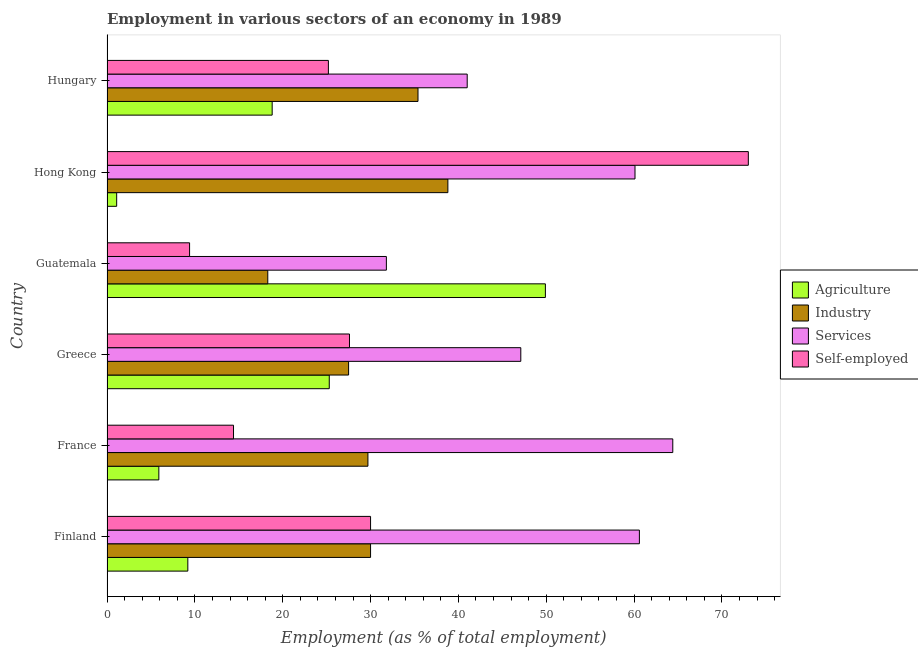How many groups of bars are there?
Make the answer very short. 6. What is the label of the 4th group of bars from the top?
Make the answer very short. Greece. Across all countries, what is the maximum percentage of workers in services?
Ensure brevity in your answer.  64.4. Across all countries, what is the minimum percentage of self employed workers?
Your response must be concise. 9.4. In which country was the percentage of workers in services minimum?
Provide a short and direct response. Guatemala. What is the total percentage of workers in services in the graph?
Provide a succinct answer. 305. What is the difference between the percentage of self employed workers in Finland and that in Greece?
Your answer should be very brief. 2.4. What is the difference between the percentage of workers in services in Guatemala and the percentage of workers in industry in France?
Provide a short and direct response. 2.1. What is the average percentage of workers in services per country?
Your answer should be compact. 50.83. What is the difference between the percentage of self employed workers and percentage of workers in industry in France?
Your answer should be compact. -15.3. In how many countries, is the percentage of workers in services greater than 60 %?
Keep it short and to the point. 3. What is the ratio of the percentage of workers in services in France to that in Guatemala?
Your response must be concise. 2.02. Is the percentage of workers in agriculture in Greece less than that in Hong Kong?
Provide a succinct answer. No. Is the difference between the percentage of workers in industry in Greece and Hong Kong greater than the difference between the percentage of workers in services in Greece and Hong Kong?
Provide a succinct answer. Yes. What is the difference between the highest and the second highest percentage of self employed workers?
Your answer should be very brief. 43. What does the 3rd bar from the top in Guatemala represents?
Keep it short and to the point. Industry. What does the 1st bar from the bottom in France represents?
Keep it short and to the point. Agriculture. Are all the bars in the graph horizontal?
Keep it short and to the point. Yes. How many legend labels are there?
Your answer should be very brief. 4. How are the legend labels stacked?
Keep it short and to the point. Vertical. What is the title of the graph?
Make the answer very short. Employment in various sectors of an economy in 1989. What is the label or title of the X-axis?
Offer a very short reply. Employment (as % of total employment). What is the Employment (as % of total employment) of Agriculture in Finland?
Keep it short and to the point. 9.2. What is the Employment (as % of total employment) of Services in Finland?
Provide a short and direct response. 60.6. What is the Employment (as % of total employment) in Self-employed in Finland?
Make the answer very short. 30. What is the Employment (as % of total employment) of Agriculture in France?
Keep it short and to the point. 5.9. What is the Employment (as % of total employment) of Industry in France?
Your answer should be very brief. 29.7. What is the Employment (as % of total employment) in Services in France?
Make the answer very short. 64.4. What is the Employment (as % of total employment) in Self-employed in France?
Your response must be concise. 14.4. What is the Employment (as % of total employment) of Agriculture in Greece?
Offer a terse response. 25.3. What is the Employment (as % of total employment) of Services in Greece?
Offer a very short reply. 47.1. What is the Employment (as % of total employment) in Self-employed in Greece?
Offer a very short reply. 27.6. What is the Employment (as % of total employment) of Agriculture in Guatemala?
Your answer should be compact. 49.9. What is the Employment (as % of total employment) of Industry in Guatemala?
Provide a succinct answer. 18.3. What is the Employment (as % of total employment) of Services in Guatemala?
Provide a short and direct response. 31.8. What is the Employment (as % of total employment) in Self-employed in Guatemala?
Ensure brevity in your answer.  9.4. What is the Employment (as % of total employment) in Agriculture in Hong Kong?
Your response must be concise. 1.1. What is the Employment (as % of total employment) of Industry in Hong Kong?
Your response must be concise. 38.8. What is the Employment (as % of total employment) in Services in Hong Kong?
Ensure brevity in your answer.  60.1. What is the Employment (as % of total employment) in Self-employed in Hong Kong?
Ensure brevity in your answer.  73. What is the Employment (as % of total employment) in Agriculture in Hungary?
Ensure brevity in your answer.  18.8. What is the Employment (as % of total employment) of Industry in Hungary?
Offer a very short reply. 35.4. What is the Employment (as % of total employment) of Self-employed in Hungary?
Ensure brevity in your answer.  25.2. Across all countries, what is the maximum Employment (as % of total employment) in Agriculture?
Provide a succinct answer. 49.9. Across all countries, what is the maximum Employment (as % of total employment) of Industry?
Your answer should be very brief. 38.8. Across all countries, what is the maximum Employment (as % of total employment) in Services?
Offer a very short reply. 64.4. Across all countries, what is the minimum Employment (as % of total employment) in Agriculture?
Your answer should be compact. 1.1. Across all countries, what is the minimum Employment (as % of total employment) of Industry?
Give a very brief answer. 18.3. Across all countries, what is the minimum Employment (as % of total employment) in Services?
Keep it short and to the point. 31.8. Across all countries, what is the minimum Employment (as % of total employment) in Self-employed?
Give a very brief answer. 9.4. What is the total Employment (as % of total employment) of Agriculture in the graph?
Provide a short and direct response. 110.2. What is the total Employment (as % of total employment) of Industry in the graph?
Offer a very short reply. 179.7. What is the total Employment (as % of total employment) of Services in the graph?
Offer a very short reply. 305. What is the total Employment (as % of total employment) in Self-employed in the graph?
Your answer should be compact. 179.6. What is the difference between the Employment (as % of total employment) in Agriculture in Finland and that in France?
Your answer should be compact. 3.3. What is the difference between the Employment (as % of total employment) of Industry in Finland and that in France?
Give a very brief answer. 0.3. What is the difference between the Employment (as % of total employment) of Services in Finland and that in France?
Offer a very short reply. -3.8. What is the difference between the Employment (as % of total employment) in Self-employed in Finland and that in France?
Give a very brief answer. 15.6. What is the difference between the Employment (as % of total employment) of Agriculture in Finland and that in Greece?
Provide a short and direct response. -16.1. What is the difference between the Employment (as % of total employment) in Agriculture in Finland and that in Guatemala?
Provide a succinct answer. -40.7. What is the difference between the Employment (as % of total employment) of Services in Finland and that in Guatemala?
Your answer should be compact. 28.8. What is the difference between the Employment (as % of total employment) in Self-employed in Finland and that in Guatemala?
Ensure brevity in your answer.  20.6. What is the difference between the Employment (as % of total employment) of Agriculture in Finland and that in Hong Kong?
Your response must be concise. 8.1. What is the difference between the Employment (as % of total employment) of Services in Finland and that in Hong Kong?
Give a very brief answer. 0.5. What is the difference between the Employment (as % of total employment) of Self-employed in Finland and that in Hong Kong?
Provide a succinct answer. -43. What is the difference between the Employment (as % of total employment) in Agriculture in Finland and that in Hungary?
Your response must be concise. -9.6. What is the difference between the Employment (as % of total employment) of Industry in Finland and that in Hungary?
Give a very brief answer. -5.4. What is the difference between the Employment (as % of total employment) of Services in Finland and that in Hungary?
Provide a succinct answer. 19.6. What is the difference between the Employment (as % of total employment) in Self-employed in Finland and that in Hungary?
Provide a succinct answer. 4.8. What is the difference between the Employment (as % of total employment) of Agriculture in France and that in Greece?
Provide a short and direct response. -19.4. What is the difference between the Employment (as % of total employment) in Industry in France and that in Greece?
Offer a terse response. 2.2. What is the difference between the Employment (as % of total employment) of Agriculture in France and that in Guatemala?
Your answer should be compact. -44. What is the difference between the Employment (as % of total employment) in Industry in France and that in Guatemala?
Ensure brevity in your answer.  11.4. What is the difference between the Employment (as % of total employment) in Services in France and that in Guatemala?
Your answer should be compact. 32.6. What is the difference between the Employment (as % of total employment) of Self-employed in France and that in Guatemala?
Your answer should be very brief. 5. What is the difference between the Employment (as % of total employment) of Agriculture in France and that in Hong Kong?
Your answer should be very brief. 4.8. What is the difference between the Employment (as % of total employment) of Industry in France and that in Hong Kong?
Your response must be concise. -9.1. What is the difference between the Employment (as % of total employment) of Services in France and that in Hong Kong?
Provide a short and direct response. 4.3. What is the difference between the Employment (as % of total employment) of Self-employed in France and that in Hong Kong?
Your response must be concise. -58.6. What is the difference between the Employment (as % of total employment) of Agriculture in France and that in Hungary?
Offer a terse response. -12.9. What is the difference between the Employment (as % of total employment) in Industry in France and that in Hungary?
Give a very brief answer. -5.7. What is the difference between the Employment (as % of total employment) of Services in France and that in Hungary?
Provide a succinct answer. 23.4. What is the difference between the Employment (as % of total employment) of Self-employed in France and that in Hungary?
Keep it short and to the point. -10.8. What is the difference between the Employment (as % of total employment) of Agriculture in Greece and that in Guatemala?
Provide a succinct answer. -24.6. What is the difference between the Employment (as % of total employment) of Services in Greece and that in Guatemala?
Offer a very short reply. 15.3. What is the difference between the Employment (as % of total employment) in Self-employed in Greece and that in Guatemala?
Offer a very short reply. 18.2. What is the difference between the Employment (as % of total employment) in Agriculture in Greece and that in Hong Kong?
Provide a short and direct response. 24.2. What is the difference between the Employment (as % of total employment) in Industry in Greece and that in Hong Kong?
Make the answer very short. -11.3. What is the difference between the Employment (as % of total employment) in Self-employed in Greece and that in Hong Kong?
Offer a very short reply. -45.4. What is the difference between the Employment (as % of total employment) of Agriculture in Greece and that in Hungary?
Ensure brevity in your answer.  6.5. What is the difference between the Employment (as % of total employment) in Agriculture in Guatemala and that in Hong Kong?
Your answer should be compact. 48.8. What is the difference between the Employment (as % of total employment) of Industry in Guatemala and that in Hong Kong?
Offer a terse response. -20.5. What is the difference between the Employment (as % of total employment) of Services in Guatemala and that in Hong Kong?
Offer a terse response. -28.3. What is the difference between the Employment (as % of total employment) in Self-employed in Guatemala and that in Hong Kong?
Make the answer very short. -63.6. What is the difference between the Employment (as % of total employment) in Agriculture in Guatemala and that in Hungary?
Provide a short and direct response. 31.1. What is the difference between the Employment (as % of total employment) of Industry in Guatemala and that in Hungary?
Your answer should be very brief. -17.1. What is the difference between the Employment (as % of total employment) in Self-employed in Guatemala and that in Hungary?
Offer a terse response. -15.8. What is the difference between the Employment (as % of total employment) in Agriculture in Hong Kong and that in Hungary?
Provide a succinct answer. -17.7. What is the difference between the Employment (as % of total employment) of Self-employed in Hong Kong and that in Hungary?
Offer a very short reply. 47.8. What is the difference between the Employment (as % of total employment) in Agriculture in Finland and the Employment (as % of total employment) in Industry in France?
Provide a short and direct response. -20.5. What is the difference between the Employment (as % of total employment) of Agriculture in Finland and the Employment (as % of total employment) of Services in France?
Provide a short and direct response. -55.2. What is the difference between the Employment (as % of total employment) in Agriculture in Finland and the Employment (as % of total employment) in Self-employed in France?
Offer a very short reply. -5.2. What is the difference between the Employment (as % of total employment) in Industry in Finland and the Employment (as % of total employment) in Services in France?
Ensure brevity in your answer.  -34.4. What is the difference between the Employment (as % of total employment) in Services in Finland and the Employment (as % of total employment) in Self-employed in France?
Provide a succinct answer. 46.2. What is the difference between the Employment (as % of total employment) of Agriculture in Finland and the Employment (as % of total employment) of Industry in Greece?
Give a very brief answer. -18.3. What is the difference between the Employment (as % of total employment) in Agriculture in Finland and the Employment (as % of total employment) in Services in Greece?
Your answer should be very brief. -37.9. What is the difference between the Employment (as % of total employment) of Agriculture in Finland and the Employment (as % of total employment) of Self-employed in Greece?
Your response must be concise. -18.4. What is the difference between the Employment (as % of total employment) in Industry in Finland and the Employment (as % of total employment) in Services in Greece?
Provide a short and direct response. -17.1. What is the difference between the Employment (as % of total employment) in Agriculture in Finland and the Employment (as % of total employment) in Services in Guatemala?
Give a very brief answer. -22.6. What is the difference between the Employment (as % of total employment) of Agriculture in Finland and the Employment (as % of total employment) of Self-employed in Guatemala?
Your answer should be very brief. -0.2. What is the difference between the Employment (as % of total employment) in Industry in Finland and the Employment (as % of total employment) in Self-employed in Guatemala?
Offer a very short reply. 20.6. What is the difference between the Employment (as % of total employment) in Services in Finland and the Employment (as % of total employment) in Self-employed in Guatemala?
Keep it short and to the point. 51.2. What is the difference between the Employment (as % of total employment) of Agriculture in Finland and the Employment (as % of total employment) of Industry in Hong Kong?
Your answer should be compact. -29.6. What is the difference between the Employment (as % of total employment) in Agriculture in Finland and the Employment (as % of total employment) in Services in Hong Kong?
Ensure brevity in your answer.  -50.9. What is the difference between the Employment (as % of total employment) in Agriculture in Finland and the Employment (as % of total employment) in Self-employed in Hong Kong?
Make the answer very short. -63.8. What is the difference between the Employment (as % of total employment) of Industry in Finland and the Employment (as % of total employment) of Services in Hong Kong?
Your response must be concise. -30.1. What is the difference between the Employment (as % of total employment) in Industry in Finland and the Employment (as % of total employment) in Self-employed in Hong Kong?
Offer a terse response. -43. What is the difference between the Employment (as % of total employment) of Services in Finland and the Employment (as % of total employment) of Self-employed in Hong Kong?
Your response must be concise. -12.4. What is the difference between the Employment (as % of total employment) in Agriculture in Finland and the Employment (as % of total employment) in Industry in Hungary?
Provide a short and direct response. -26.2. What is the difference between the Employment (as % of total employment) in Agriculture in Finland and the Employment (as % of total employment) in Services in Hungary?
Offer a terse response. -31.8. What is the difference between the Employment (as % of total employment) in Agriculture in Finland and the Employment (as % of total employment) in Self-employed in Hungary?
Offer a terse response. -16. What is the difference between the Employment (as % of total employment) of Services in Finland and the Employment (as % of total employment) of Self-employed in Hungary?
Your answer should be very brief. 35.4. What is the difference between the Employment (as % of total employment) in Agriculture in France and the Employment (as % of total employment) in Industry in Greece?
Provide a short and direct response. -21.6. What is the difference between the Employment (as % of total employment) in Agriculture in France and the Employment (as % of total employment) in Services in Greece?
Your answer should be compact. -41.2. What is the difference between the Employment (as % of total employment) of Agriculture in France and the Employment (as % of total employment) of Self-employed in Greece?
Your answer should be very brief. -21.7. What is the difference between the Employment (as % of total employment) of Industry in France and the Employment (as % of total employment) of Services in Greece?
Make the answer very short. -17.4. What is the difference between the Employment (as % of total employment) of Services in France and the Employment (as % of total employment) of Self-employed in Greece?
Your answer should be compact. 36.8. What is the difference between the Employment (as % of total employment) in Agriculture in France and the Employment (as % of total employment) in Industry in Guatemala?
Your answer should be very brief. -12.4. What is the difference between the Employment (as % of total employment) of Agriculture in France and the Employment (as % of total employment) of Services in Guatemala?
Make the answer very short. -25.9. What is the difference between the Employment (as % of total employment) in Industry in France and the Employment (as % of total employment) in Self-employed in Guatemala?
Offer a terse response. 20.3. What is the difference between the Employment (as % of total employment) of Services in France and the Employment (as % of total employment) of Self-employed in Guatemala?
Keep it short and to the point. 55. What is the difference between the Employment (as % of total employment) in Agriculture in France and the Employment (as % of total employment) in Industry in Hong Kong?
Provide a short and direct response. -32.9. What is the difference between the Employment (as % of total employment) in Agriculture in France and the Employment (as % of total employment) in Services in Hong Kong?
Provide a succinct answer. -54.2. What is the difference between the Employment (as % of total employment) of Agriculture in France and the Employment (as % of total employment) of Self-employed in Hong Kong?
Make the answer very short. -67.1. What is the difference between the Employment (as % of total employment) in Industry in France and the Employment (as % of total employment) in Services in Hong Kong?
Provide a succinct answer. -30.4. What is the difference between the Employment (as % of total employment) in Industry in France and the Employment (as % of total employment) in Self-employed in Hong Kong?
Provide a succinct answer. -43.3. What is the difference between the Employment (as % of total employment) of Services in France and the Employment (as % of total employment) of Self-employed in Hong Kong?
Provide a succinct answer. -8.6. What is the difference between the Employment (as % of total employment) of Agriculture in France and the Employment (as % of total employment) of Industry in Hungary?
Offer a terse response. -29.5. What is the difference between the Employment (as % of total employment) of Agriculture in France and the Employment (as % of total employment) of Services in Hungary?
Provide a short and direct response. -35.1. What is the difference between the Employment (as % of total employment) of Agriculture in France and the Employment (as % of total employment) of Self-employed in Hungary?
Provide a short and direct response. -19.3. What is the difference between the Employment (as % of total employment) of Industry in France and the Employment (as % of total employment) of Services in Hungary?
Provide a short and direct response. -11.3. What is the difference between the Employment (as % of total employment) in Services in France and the Employment (as % of total employment) in Self-employed in Hungary?
Provide a short and direct response. 39.2. What is the difference between the Employment (as % of total employment) in Agriculture in Greece and the Employment (as % of total employment) in Industry in Guatemala?
Make the answer very short. 7. What is the difference between the Employment (as % of total employment) in Agriculture in Greece and the Employment (as % of total employment) in Services in Guatemala?
Offer a very short reply. -6.5. What is the difference between the Employment (as % of total employment) of Agriculture in Greece and the Employment (as % of total employment) of Self-employed in Guatemala?
Your answer should be compact. 15.9. What is the difference between the Employment (as % of total employment) of Industry in Greece and the Employment (as % of total employment) of Self-employed in Guatemala?
Offer a very short reply. 18.1. What is the difference between the Employment (as % of total employment) in Services in Greece and the Employment (as % of total employment) in Self-employed in Guatemala?
Your answer should be compact. 37.7. What is the difference between the Employment (as % of total employment) in Agriculture in Greece and the Employment (as % of total employment) in Services in Hong Kong?
Give a very brief answer. -34.8. What is the difference between the Employment (as % of total employment) in Agriculture in Greece and the Employment (as % of total employment) in Self-employed in Hong Kong?
Provide a short and direct response. -47.7. What is the difference between the Employment (as % of total employment) in Industry in Greece and the Employment (as % of total employment) in Services in Hong Kong?
Keep it short and to the point. -32.6. What is the difference between the Employment (as % of total employment) in Industry in Greece and the Employment (as % of total employment) in Self-employed in Hong Kong?
Make the answer very short. -45.5. What is the difference between the Employment (as % of total employment) of Services in Greece and the Employment (as % of total employment) of Self-employed in Hong Kong?
Make the answer very short. -25.9. What is the difference between the Employment (as % of total employment) of Agriculture in Greece and the Employment (as % of total employment) of Services in Hungary?
Your answer should be very brief. -15.7. What is the difference between the Employment (as % of total employment) in Industry in Greece and the Employment (as % of total employment) in Self-employed in Hungary?
Provide a short and direct response. 2.3. What is the difference between the Employment (as % of total employment) in Services in Greece and the Employment (as % of total employment) in Self-employed in Hungary?
Give a very brief answer. 21.9. What is the difference between the Employment (as % of total employment) of Agriculture in Guatemala and the Employment (as % of total employment) of Services in Hong Kong?
Keep it short and to the point. -10.2. What is the difference between the Employment (as % of total employment) in Agriculture in Guatemala and the Employment (as % of total employment) in Self-employed in Hong Kong?
Your answer should be very brief. -23.1. What is the difference between the Employment (as % of total employment) of Industry in Guatemala and the Employment (as % of total employment) of Services in Hong Kong?
Your response must be concise. -41.8. What is the difference between the Employment (as % of total employment) in Industry in Guatemala and the Employment (as % of total employment) in Self-employed in Hong Kong?
Offer a very short reply. -54.7. What is the difference between the Employment (as % of total employment) of Services in Guatemala and the Employment (as % of total employment) of Self-employed in Hong Kong?
Offer a very short reply. -41.2. What is the difference between the Employment (as % of total employment) of Agriculture in Guatemala and the Employment (as % of total employment) of Industry in Hungary?
Ensure brevity in your answer.  14.5. What is the difference between the Employment (as % of total employment) of Agriculture in Guatemala and the Employment (as % of total employment) of Self-employed in Hungary?
Make the answer very short. 24.7. What is the difference between the Employment (as % of total employment) in Industry in Guatemala and the Employment (as % of total employment) in Services in Hungary?
Your answer should be very brief. -22.7. What is the difference between the Employment (as % of total employment) in Industry in Guatemala and the Employment (as % of total employment) in Self-employed in Hungary?
Ensure brevity in your answer.  -6.9. What is the difference between the Employment (as % of total employment) in Services in Guatemala and the Employment (as % of total employment) in Self-employed in Hungary?
Your answer should be compact. 6.6. What is the difference between the Employment (as % of total employment) in Agriculture in Hong Kong and the Employment (as % of total employment) in Industry in Hungary?
Offer a terse response. -34.3. What is the difference between the Employment (as % of total employment) in Agriculture in Hong Kong and the Employment (as % of total employment) in Services in Hungary?
Your answer should be very brief. -39.9. What is the difference between the Employment (as % of total employment) in Agriculture in Hong Kong and the Employment (as % of total employment) in Self-employed in Hungary?
Your response must be concise. -24.1. What is the difference between the Employment (as % of total employment) of Services in Hong Kong and the Employment (as % of total employment) of Self-employed in Hungary?
Give a very brief answer. 34.9. What is the average Employment (as % of total employment) in Agriculture per country?
Give a very brief answer. 18.37. What is the average Employment (as % of total employment) in Industry per country?
Provide a short and direct response. 29.95. What is the average Employment (as % of total employment) of Services per country?
Provide a succinct answer. 50.83. What is the average Employment (as % of total employment) of Self-employed per country?
Provide a succinct answer. 29.93. What is the difference between the Employment (as % of total employment) of Agriculture and Employment (as % of total employment) of Industry in Finland?
Keep it short and to the point. -20.8. What is the difference between the Employment (as % of total employment) in Agriculture and Employment (as % of total employment) in Services in Finland?
Keep it short and to the point. -51.4. What is the difference between the Employment (as % of total employment) in Agriculture and Employment (as % of total employment) in Self-employed in Finland?
Provide a short and direct response. -20.8. What is the difference between the Employment (as % of total employment) in Industry and Employment (as % of total employment) in Services in Finland?
Offer a terse response. -30.6. What is the difference between the Employment (as % of total employment) of Industry and Employment (as % of total employment) of Self-employed in Finland?
Your answer should be very brief. 0. What is the difference between the Employment (as % of total employment) in Services and Employment (as % of total employment) in Self-employed in Finland?
Your answer should be very brief. 30.6. What is the difference between the Employment (as % of total employment) of Agriculture and Employment (as % of total employment) of Industry in France?
Keep it short and to the point. -23.8. What is the difference between the Employment (as % of total employment) in Agriculture and Employment (as % of total employment) in Services in France?
Offer a terse response. -58.5. What is the difference between the Employment (as % of total employment) of Agriculture and Employment (as % of total employment) of Self-employed in France?
Give a very brief answer. -8.5. What is the difference between the Employment (as % of total employment) of Industry and Employment (as % of total employment) of Services in France?
Provide a short and direct response. -34.7. What is the difference between the Employment (as % of total employment) in Agriculture and Employment (as % of total employment) in Industry in Greece?
Provide a short and direct response. -2.2. What is the difference between the Employment (as % of total employment) in Agriculture and Employment (as % of total employment) in Services in Greece?
Your response must be concise. -21.8. What is the difference between the Employment (as % of total employment) of Industry and Employment (as % of total employment) of Services in Greece?
Make the answer very short. -19.6. What is the difference between the Employment (as % of total employment) of Industry and Employment (as % of total employment) of Self-employed in Greece?
Your answer should be compact. -0.1. What is the difference between the Employment (as % of total employment) of Services and Employment (as % of total employment) of Self-employed in Greece?
Offer a very short reply. 19.5. What is the difference between the Employment (as % of total employment) in Agriculture and Employment (as % of total employment) in Industry in Guatemala?
Provide a short and direct response. 31.6. What is the difference between the Employment (as % of total employment) in Agriculture and Employment (as % of total employment) in Self-employed in Guatemala?
Your answer should be very brief. 40.5. What is the difference between the Employment (as % of total employment) in Industry and Employment (as % of total employment) in Services in Guatemala?
Ensure brevity in your answer.  -13.5. What is the difference between the Employment (as % of total employment) in Industry and Employment (as % of total employment) in Self-employed in Guatemala?
Your answer should be very brief. 8.9. What is the difference between the Employment (as % of total employment) in Services and Employment (as % of total employment) in Self-employed in Guatemala?
Give a very brief answer. 22.4. What is the difference between the Employment (as % of total employment) of Agriculture and Employment (as % of total employment) of Industry in Hong Kong?
Give a very brief answer. -37.7. What is the difference between the Employment (as % of total employment) of Agriculture and Employment (as % of total employment) of Services in Hong Kong?
Offer a terse response. -59. What is the difference between the Employment (as % of total employment) of Agriculture and Employment (as % of total employment) of Self-employed in Hong Kong?
Your answer should be compact. -71.9. What is the difference between the Employment (as % of total employment) of Industry and Employment (as % of total employment) of Services in Hong Kong?
Provide a succinct answer. -21.3. What is the difference between the Employment (as % of total employment) in Industry and Employment (as % of total employment) in Self-employed in Hong Kong?
Make the answer very short. -34.2. What is the difference between the Employment (as % of total employment) of Agriculture and Employment (as % of total employment) of Industry in Hungary?
Your answer should be compact. -16.6. What is the difference between the Employment (as % of total employment) of Agriculture and Employment (as % of total employment) of Services in Hungary?
Ensure brevity in your answer.  -22.2. What is the difference between the Employment (as % of total employment) of Industry and Employment (as % of total employment) of Services in Hungary?
Give a very brief answer. -5.6. What is the difference between the Employment (as % of total employment) of Services and Employment (as % of total employment) of Self-employed in Hungary?
Keep it short and to the point. 15.8. What is the ratio of the Employment (as % of total employment) of Agriculture in Finland to that in France?
Ensure brevity in your answer.  1.56. What is the ratio of the Employment (as % of total employment) of Industry in Finland to that in France?
Provide a short and direct response. 1.01. What is the ratio of the Employment (as % of total employment) of Services in Finland to that in France?
Give a very brief answer. 0.94. What is the ratio of the Employment (as % of total employment) of Self-employed in Finland to that in France?
Offer a very short reply. 2.08. What is the ratio of the Employment (as % of total employment) in Agriculture in Finland to that in Greece?
Ensure brevity in your answer.  0.36. What is the ratio of the Employment (as % of total employment) of Services in Finland to that in Greece?
Keep it short and to the point. 1.29. What is the ratio of the Employment (as % of total employment) in Self-employed in Finland to that in Greece?
Your answer should be very brief. 1.09. What is the ratio of the Employment (as % of total employment) in Agriculture in Finland to that in Guatemala?
Make the answer very short. 0.18. What is the ratio of the Employment (as % of total employment) in Industry in Finland to that in Guatemala?
Provide a short and direct response. 1.64. What is the ratio of the Employment (as % of total employment) of Services in Finland to that in Guatemala?
Offer a very short reply. 1.91. What is the ratio of the Employment (as % of total employment) of Self-employed in Finland to that in Guatemala?
Make the answer very short. 3.19. What is the ratio of the Employment (as % of total employment) in Agriculture in Finland to that in Hong Kong?
Your response must be concise. 8.36. What is the ratio of the Employment (as % of total employment) in Industry in Finland to that in Hong Kong?
Ensure brevity in your answer.  0.77. What is the ratio of the Employment (as % of total employment) of Services in Finland to that in Hong Kong?
Offer a terse response. 1.01. What is the ratio of the Employment (as % of total employment) in Self-employed in Finland to that in Hong Kong?
Ensure brevity in your answer.  0.41. What is the ratio of the Employment (as % of total employment) of Agriculture in Finland to that in Hungary?
Keep it short and to the point. 0.49. What is the ratio of the Employment (as % of total employment) of Industry in Finland to that in Hungary?
Provide a short and direct response. 0.85. What is the ratio of the Employment (as % of total employment) of Services in Finland to that in Hungary?
Offer a very short reply. 1.48. What is the ratio of the Employment (as % of total employment) in Self-employed in Finland to that in Hungary?
Give a very brief answer. 1.19. What is the ratio of the Employment (as % of total employment) in Agriculture in France to that in Greece?
Ensure brevity in your answer.  0.23. What is the ratio of the Employment (as % of total employment) of Industry in France to that in Greece?
Keep it short and to the point. 1.08. What is the ratio of the Employment (as % of total employment) of Services in France to that in Greece?
Your response must be concise. 1.37. What is the ratio of the Employment (as % of total employment) of Self-employed in France to that in Greece?
Offer a very short reply. 0.52. What is the ratio of the Employment (as % of total employment) in Agriculture in France to that in Guatemala?
Offer a very short reply. 0.12. What is the ratio of the Employment (as % of total employment) in Industry in France to that in Guatemala?
Make the answer very short. 1.62. What is the ratio of the Employment (as % of total employment) of Services in France to that in Guatemala?
Your response must be concise. 2.03. What is the ratio of the Employment (as % of total employment) in Self-employed in France to that in Guatemala?
Your answer should be compact. 1.53. What is the ratio of the Employment (as % of total employment) of Agriculture in France to that in Hong Kong?
Provide a short and direct response. 5.36. What is the ratio of the Employment (as % of total employment) in Industry in France to that in Hong Kong?
Offer a terse response. 0.77. What is the ratio of the Employment (as % of total employment) of Services in France to that in Hong Kong?
Offer a very short reply. 1.07. What is the ratio of the Employment (as % of total employment) of Self-employed in France to that in Hong Kong?
Keep it short and to the point. 0.2. What is the ratio of the Employment (as % of total employment) in Agriculture in France to that in Hungary?
Your answer should be compact. 0.31. What is the ratio of the Employment (as % of total employment) in Industry in France to that in Hungary?
Provide a succinct answer. 0.84. What is the ratio of the Employment (as % of total employment) of Services in France to that in Hungary?
Give a very brief answer. 1.57. What is the ratio of the Employment (as % of total employment) of Agriculture in Greece to that in Guatemala?
Give a very brief answer. 0.51. What is the ratio of the Employment (as % of total employment) in Industry in Greece to that in Guatemala?
Offer a very short reply. 1.5. What is the ratio of the Employment (as % of total employment) in Services in Greece to that in Guatemala?
Offer a very short reply. 1.48. What is the ratio of the Employment (as % of total employment) of Self-employed in Greece to that in Guatemala?
Provide a short and direct response. 2.94. What is the ratio of the Employment (as % of total employment) of Industry in Greece to that in Hong Kong?
Your answer should be very brief. 0.71. What is the ratio of the Employment (as % of total employment) of Services in Greece to that in Hong Kong?
Give a very brief answer. 0.78. What is the ratio of the Employment (as % of total employment) in Self-employed in Greece to that in Hong Kong?
Offer a very short reply. 0.38. What is the ratio of the Employment (as % of total employment) in Agriculture in Greece to that in Hungary?
Your answer should be compact. 1.35. What is the ratio of the Employment (as % of total employment) in Industry in Greece to that in Hungary?
Ensure brevity in your answer.  0.78. What is the ratio of the Employment (as % of total employment) of Services in Greece to that in Hungary?
Your response must be concise. 1.15. What is the ratio of the Employment (as % of total employment) of Self-employed in Greece to that in Hungary?
Ensure brevity in your answer.  1.1. What is the ratio of the Employment (as % of total employment) in Agriculture in Guatemala to that in Hong Kong?
Give a very brief answer. 45.36. What is the ratio of the Employment (as % of total employment) of Industry in Guatemala to that in Hong Kong?
Offer a very short reply. 0.47. What is the ratio of the Employment (as % of total employment) of Services in Guatemala to that in Hong Kong?
Keep it short and to the point. 0.53. What is the ratio of the Employment (as % of total employment) in Self-employed in Guatemala to that in Hong Kong?
Ensure brevity in your answer.  0.13. What is the ratio of the Employment (as % of total employment) in Agriculture in Guatemala to that in Hungary?
Make the answer very short. 2.65. What is the ratio of the Employment (as % of total employment) in Industry in Guatemala to that in Hungary?
Your response must be concise. 0.52. What is the ratio of the Employment (as % of total employment) of Services in Guatemala to that in Hungary?
Provide a succinct answer. 0.78. What is the ratio of the Employment (as % of total employment) in Self-employed in Guatemala to that in Hungary?
Make the answer very short. 0.37. What is the ratio of the Employment (as % of total employment) of Agriculture in Hong Kong to that in Hungary?
Keep it short and to the point. 0.06. What is the ratio of the Employment (as % of total employment) in Industry in Hong Kong to that in Hungary?
Your response must be concise. 1.1. What is the ratio of the Employment (as % of total employment) in Services in Hong Kong to that in Hungary?
Keep it short and to the point. 1.47. What is the ratio of the Employment (as % of total employment) in Self-employed in Hong Kong to that in Hungary?
Your answer should be very brief. 2.9. What is the difference between the highest and the second highest Employment (as % of total employment) in Agriculture?
Your answer should be compact. 24.6. What is the difference between the highest and the second highest Employment (as % of total employment) in Industry?
Your response must be concise. 3.4. What is the difference between the highest and the second highest Employment (as % of total employment) of Services?
Offer a very short reply. 3.8. What is the difference between the highest and the second highest Employment (as % of total employment) in Self-employed?
Ensure brevity in your answer.  43. What is the difference between the highest and the lowest Employment (as % of total employment) of Agriculture?
Keep it short and to the point. 48.8. What is the difference between the highest and the lowest Employment (as % of total employment) in Services?
Offer a very short reply. 32.6. What is the difference between the highest and the lowest Employment (as % of total employment) in Self-employed?
Provide a short and direct response. 63.6. 